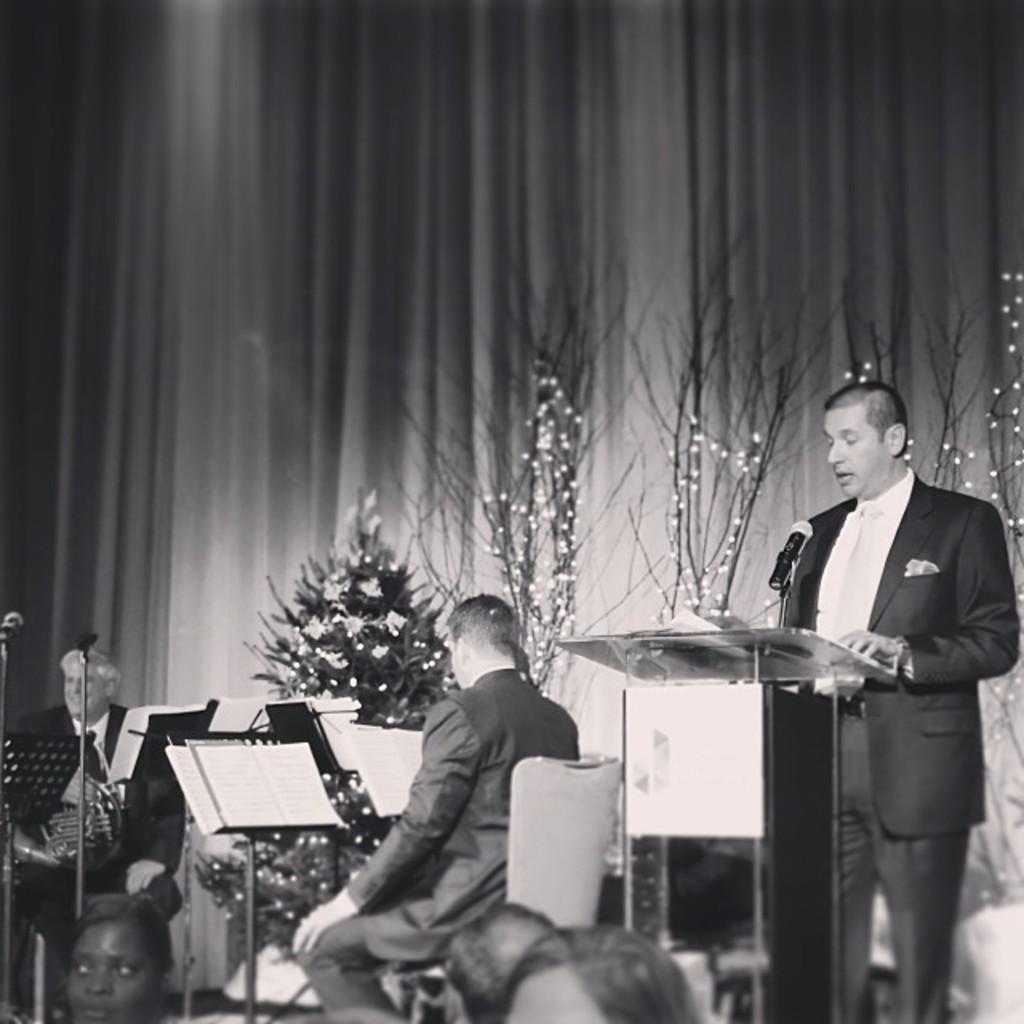How would you summarize this image in a sentence or two? In this image we can see some persons sitting on chairs singing, at the foreground of the image there is person wearing suit standing behind the block and there is microphone on it and at the background of the image there are some plants and curtains. 